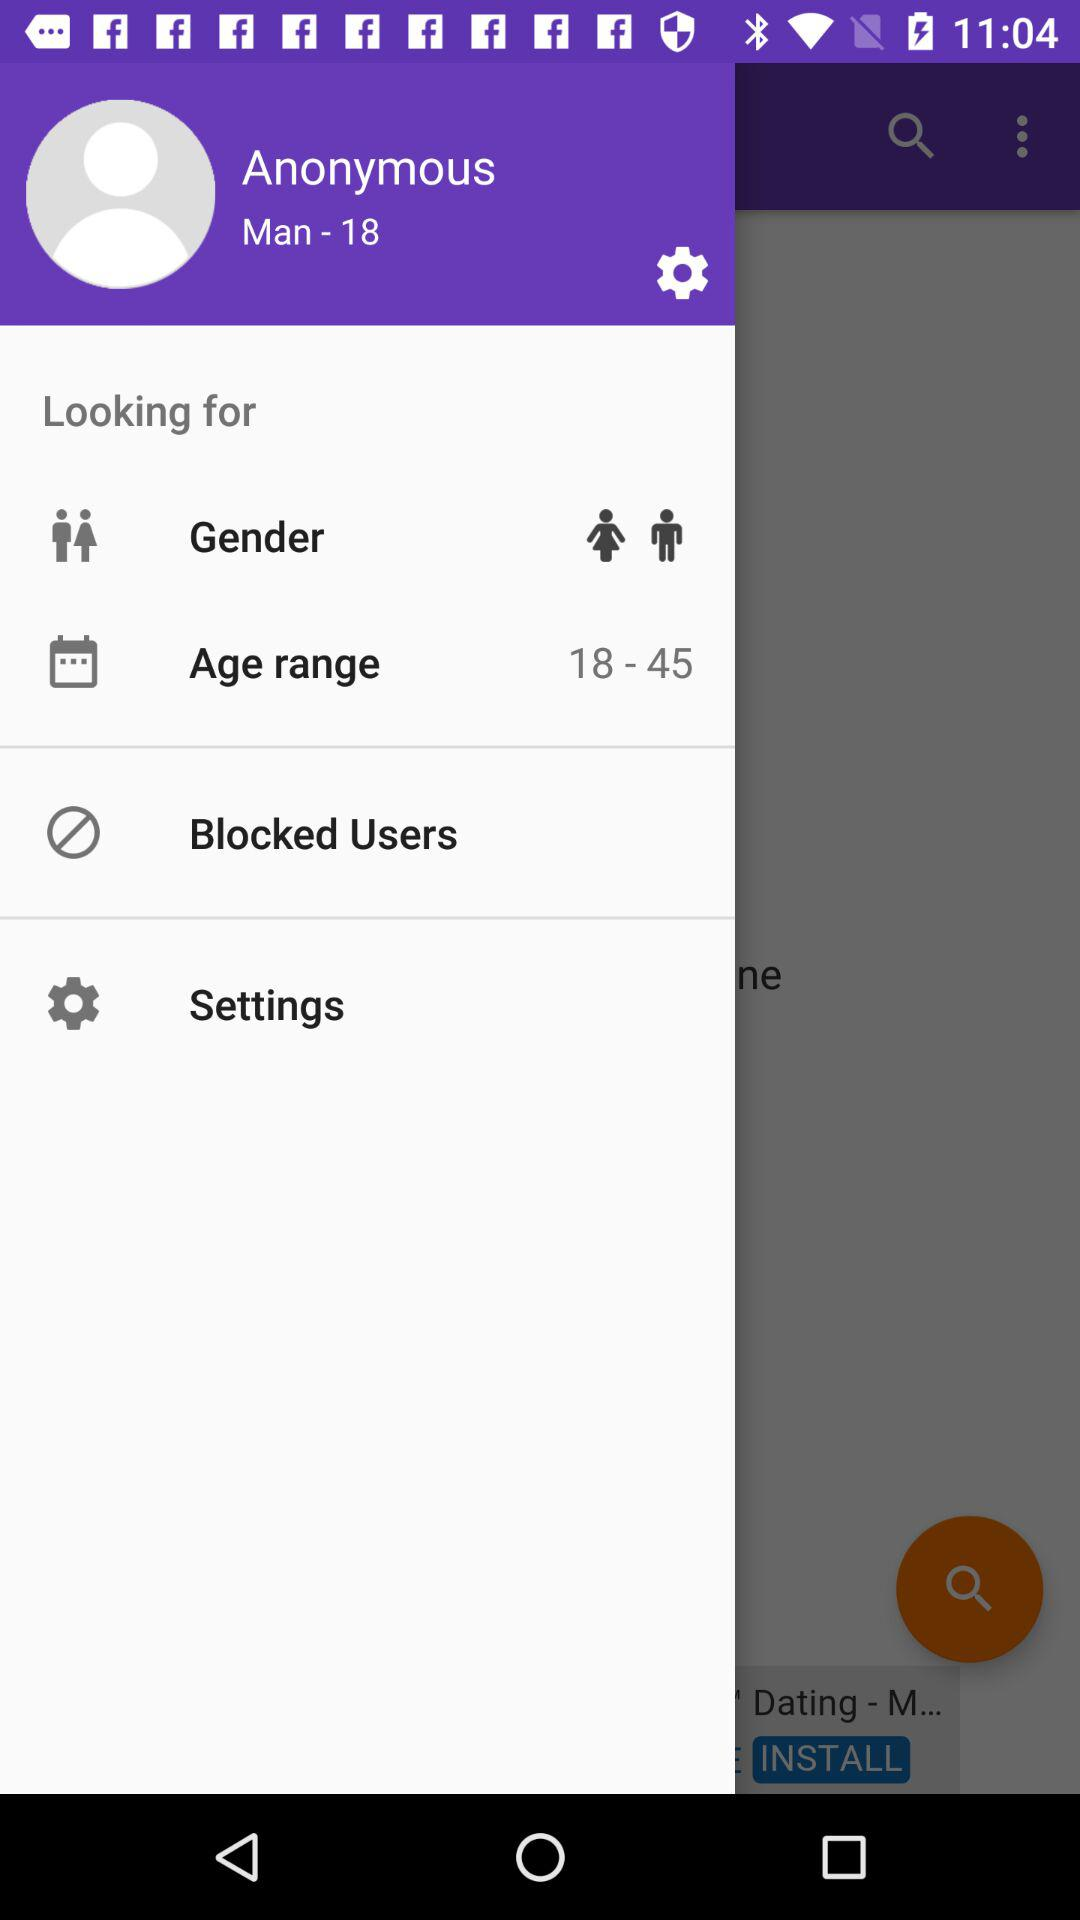What s the age? The age is 18. 